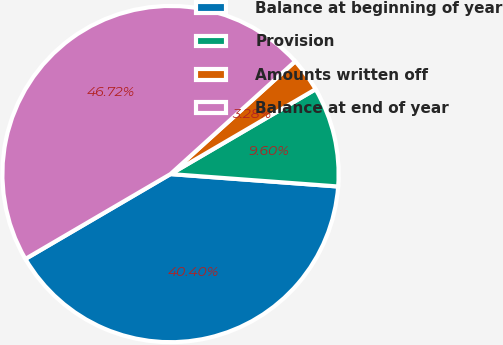<chart> <loc_0><loc_0><loc_500><loc_500><pie_chart><fcel>Balance at beginning of year<fcel>Provision<fcel>Amounts written off<fcel>Balance at end of year<nl><fcel>40.4%<fcel>9.6%<fcel>3.28%<fcel>46.72%<nl></chart> 